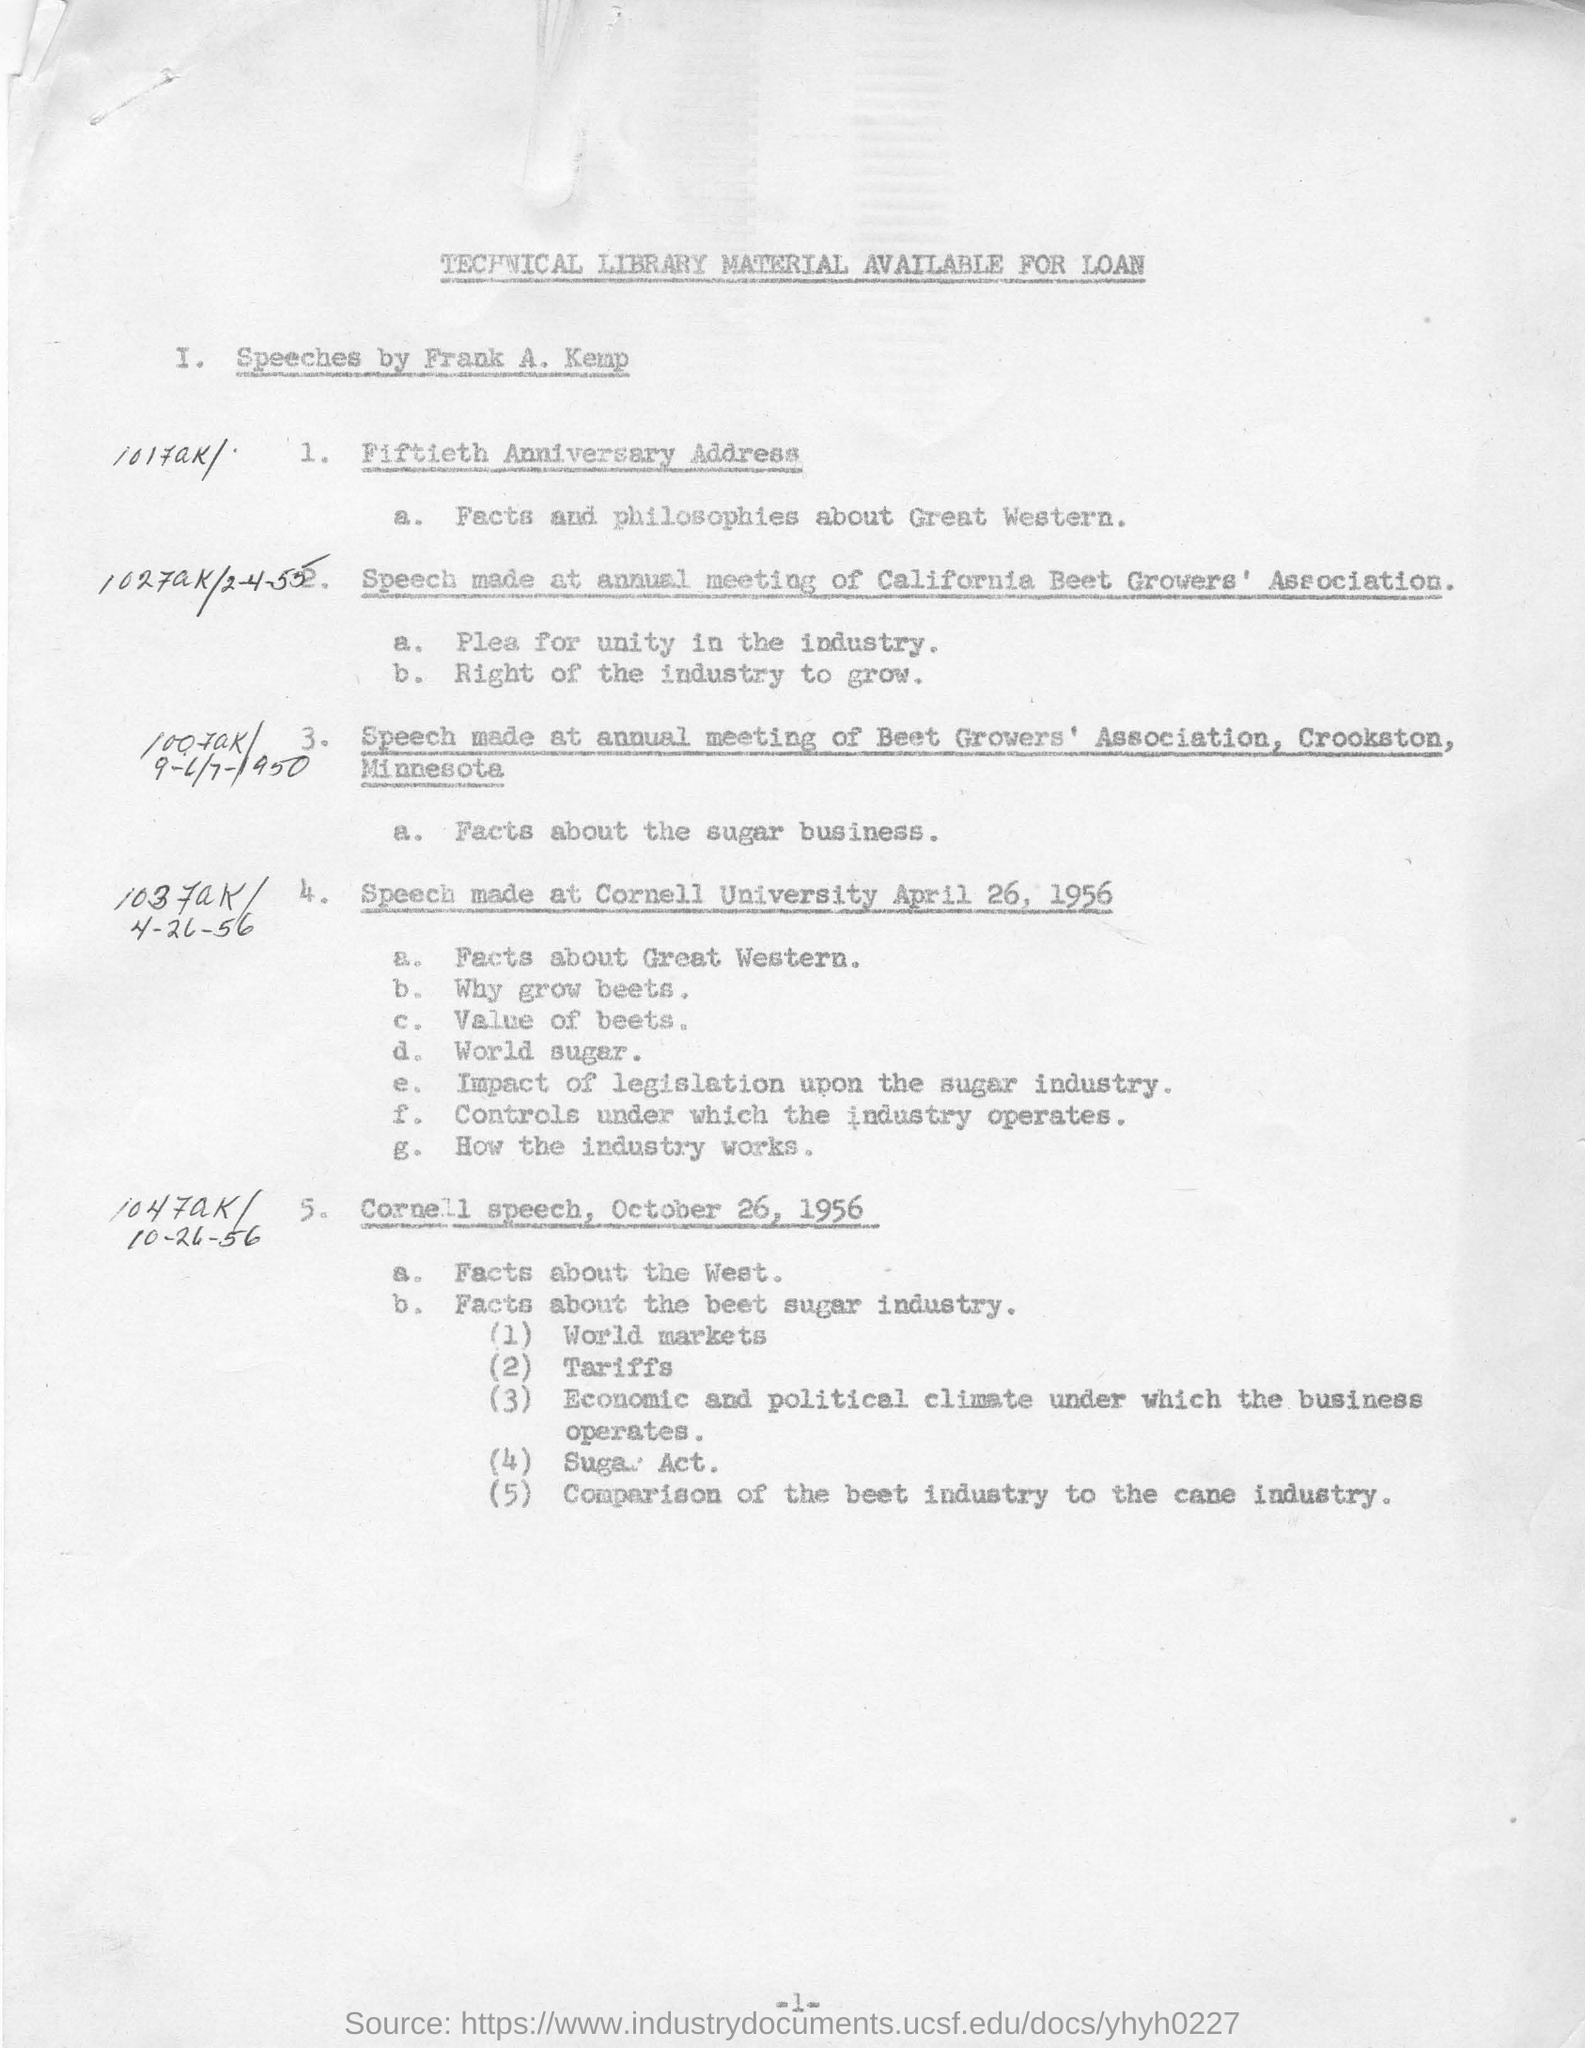Indicate a few pertinent items in this graphic. The Sugar Act was introduced in October, as stated in the speaker's speech. In a speech delivered on October 26, 1956, known as the "Cornell speech," the comparison of the best cane industry was discussed. The main fact discussed in the fiftieth anniversary address is the importance of facts and philosophies about the Great Western. The first Cornell University speech was held on April 26, 1956. 